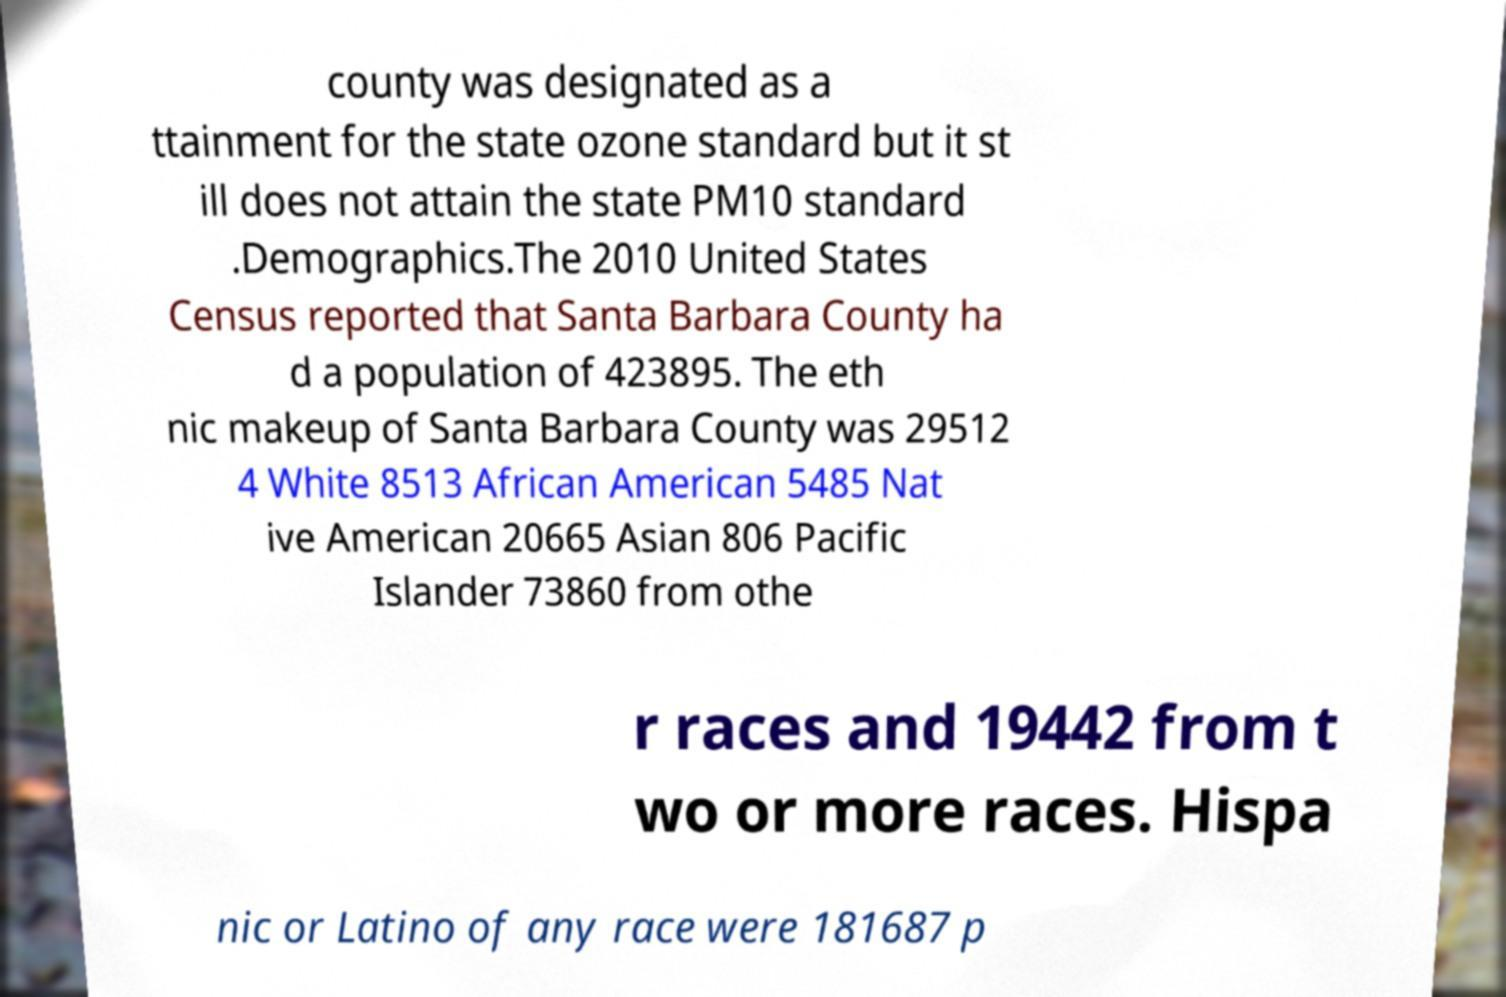Could you assist in decoding the text presented in this image and type it out clearly? county was designated as a ttainment for the state ozone standard but it st ill does not attain the state PM10 standard .Demographics.The 2010 United States Census reported that Santa Barbara County ha d a population of 423895. The eth nic makeup of Santa Barbara County was 29512 4 White 8513 African American 5485 Nat ive American 20665 Asian 806 Pacific Islander 73860 from othe r races and 19442 from t wo or more races. Hispa nic or Latino of any race were 181687 p 